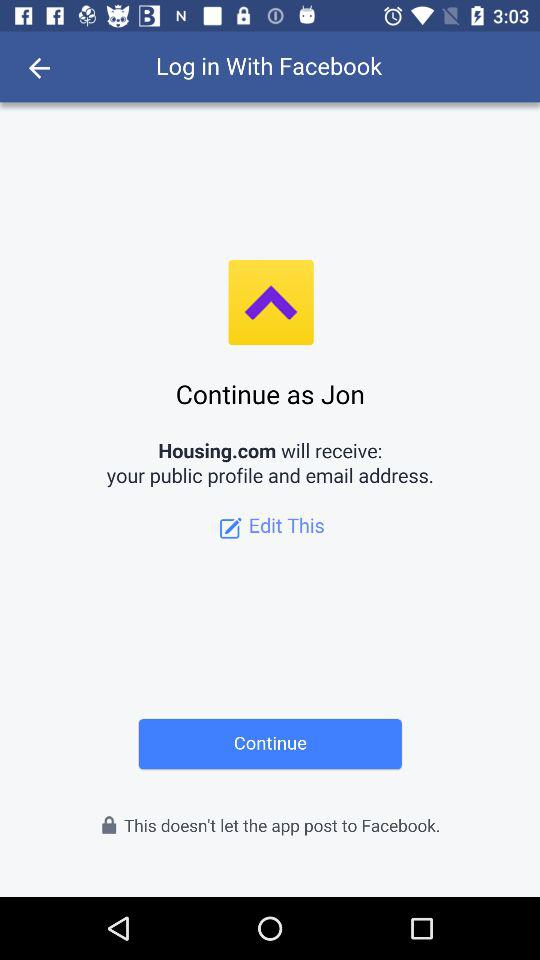What is the user name? The user name is "Jon". 